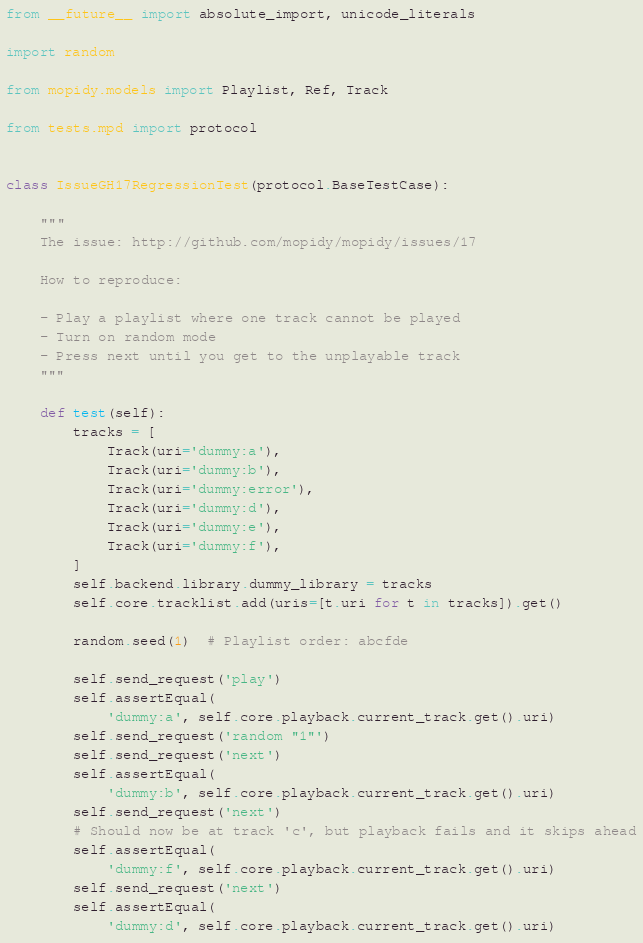<code> <loc_0><loc_0><loc_500><loc_500><_Python_>from __future__ import absolute_import, unicode_literals

import random

from mopidy.models import Playlist, Ref, Track

from tests.mpd import protocol


class IssueGH17RegressionTest(protocol.BaseTestCase):

    """
    The issue: http://github.com/mopidy/mopidy/issues/17

    How to reproduce:

    - Play a playlist where one track cannot be played
    - Turn on random mode
    - Press next until you get to the unplayable track
    """

    def test(self):
        tracks = [
            Track(uri='dummy:a'),
            Track(uri='dummy:b'),
            Track(uri='dummy:error'),
            Track(uri='dummy:d'),
            Track(uri='dummy:e'),
            Track(uri='dummy:f'),
        ]
        self.backend.library.dummy_library = tracks
        self.core.tracklist.add(uris=[t.uri for t in tracks]).get()

        random.seed(1)  # Playlist order: abcfde

        self.send_request('play')
        self.assertEqual(
            'dummy:a', self.core.playback.current_track.get().uri)
        self.send_request('random "1"')
        self.send_request('next')
        self.assertEqual(
            'dummy:b', self.core.playback.current_track.get().uri)
        self.send_request('next')
        # Should now be at track 'c', but playback fails and it skips ahead
        self.assertEqual(
            'dummy:f', self.core.playback.current_track.get().uri)
        self.send_request('next')
        self.assertEqual(
            'dummy:d', self.core.playback.current_track.get().uri)</code> 